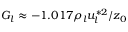Convert formula to latex. <formula><loc_0><loc_0><loc_500><loc_500>G _ { l } \approx - 1 . 0 1 7 \rho _ { l } u _ { l } ^ { * 2 } / z _ { 0 }</formula> 